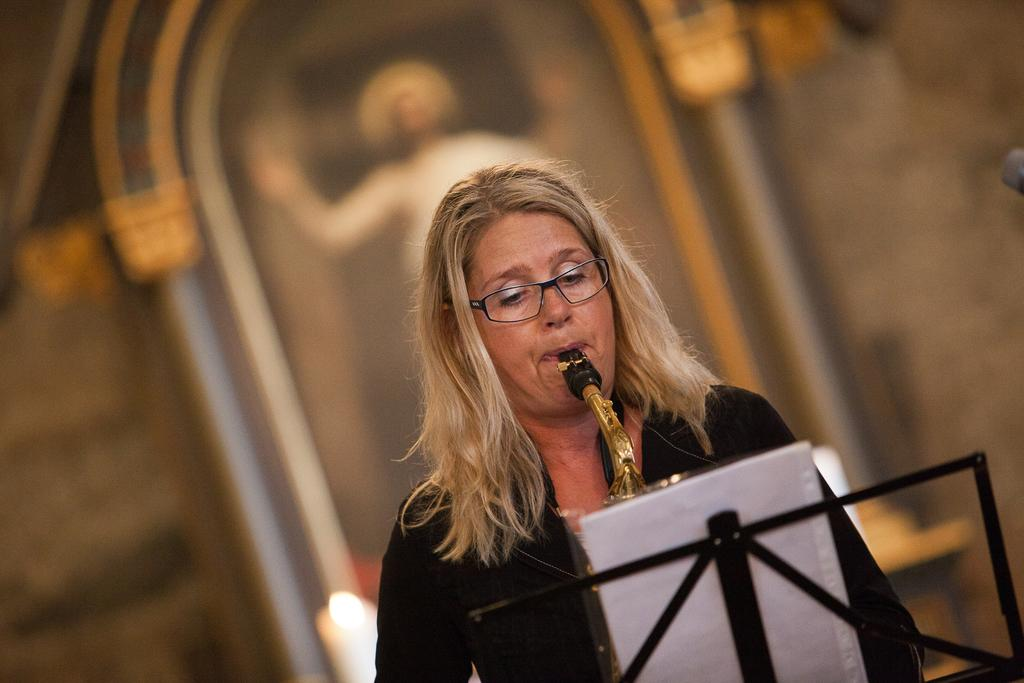Who is the main subject in the image? There is a woman in the image. What is the woman doing in the image? The woman is playing a musical instrument. What can be seen in front of the woman? There is an object on a stand in front of the woman. Can you describe the background of the image? The background of the image is blurred. What color of paint is being used by the woman in the image? There is no paint or painting activity present in the image. What shape is the square object on the stand in front of the woman? There is no square object present in the image; only an object on a stand is mentioned. 